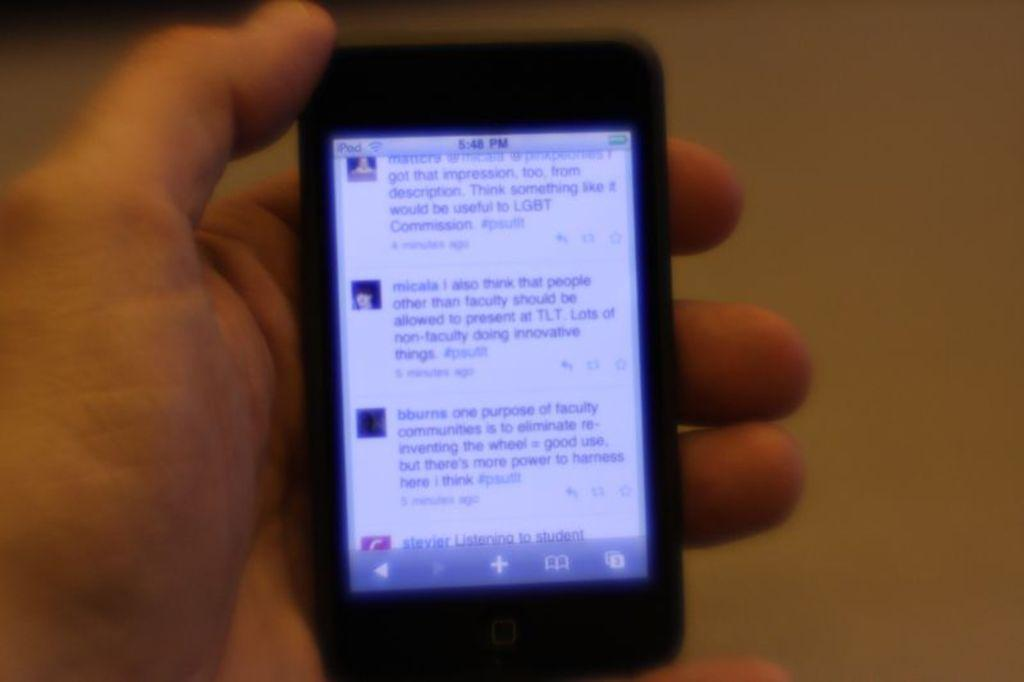What is the person's hand holding in the image? The person's hand is holding a mobile in the image. Can you describe the background of the image? The background of the image is blurred. What type of muscle is visible in the image? There is no muscle visible in the image; it only shows a person's hand holding a mobile. 